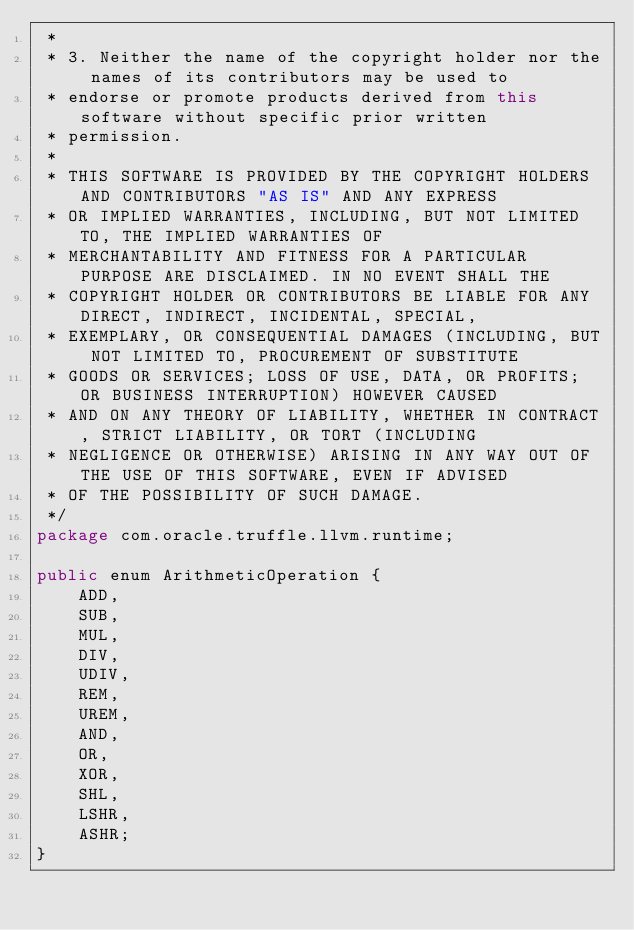Convert code to text. <code><loc_0><loc_0><loc_500><loc_500><_Java_> *
 * 3. Neither the name of the copyright holder nor the names of its contributors may be used to
 * endorse or promote products derived from this software without specific prior written
 * permission.
 *
 * THIS SOFTWARE IS PROVIDED BY THE COPYRIGHT HOLDERS AND CONTRIBUTORS "AS IS" AND ANY EXPRESS
 * OR IMPLIED WARRANTIES, INCLUDING, BUT NOT LIMITED TO, THE IMPLIED WARRANTIES OF
 * MERCHANTABILITY AND FITNESS FOR A PARTICULAR PURPOSE ARE DISCLAIMED. IN NO EVENT SHALL THE
 * COPYRIGHT HOLDER OR CONTRIBUTORS BE LIABLE FOR ANY DIRECT, INDIRECT, INCIDENTAL, SPECIAL,
 * EXEMPLARY, OR CONSEQUENTIAL DAMAGES (INCLUDING, BUT NOT LIMITED TO, PROCUREMENT OF SUBSTITUTE
 * GOODS OR SERVICES; LOSS OF USE, DATA, OR PROFITS; OR BUSINESS INTERRUPTION) HOWEVER CAUSED
 * AND ON ANY THEORY OF LIABILITY, WHETHER IN CONTRACT, STRICT LIABILITY, OR TORT (INCLUDING
 * NEGLIGENCE OR OTHERWISE) ARISING IN ANY WAY OUT OF THE USE OF THIS SOFTWARE, EVEN IF ADVISED
 * OF THE POSSIBILITY OF SUCH DAMAGE.
 */
package com.oracle.truffle.llvm.runtime;

public enum ArithmeticOperation {
    ADD,
    SUB,
    MUL,
    DIV,
    UDIV,
    REM,
    UREM,
    AND,
    OR,
    XOR,
    SHL,
    LSHR,
    ASHR;
}
</code> 